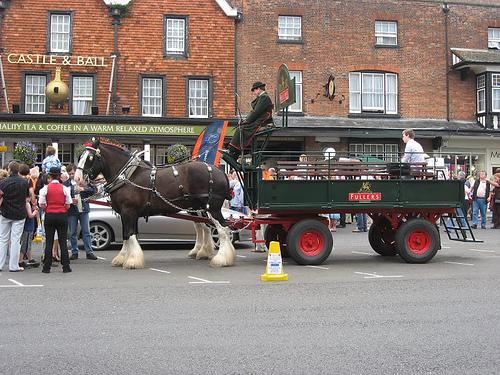What color are the bearings inside of the wagon wheels? red 